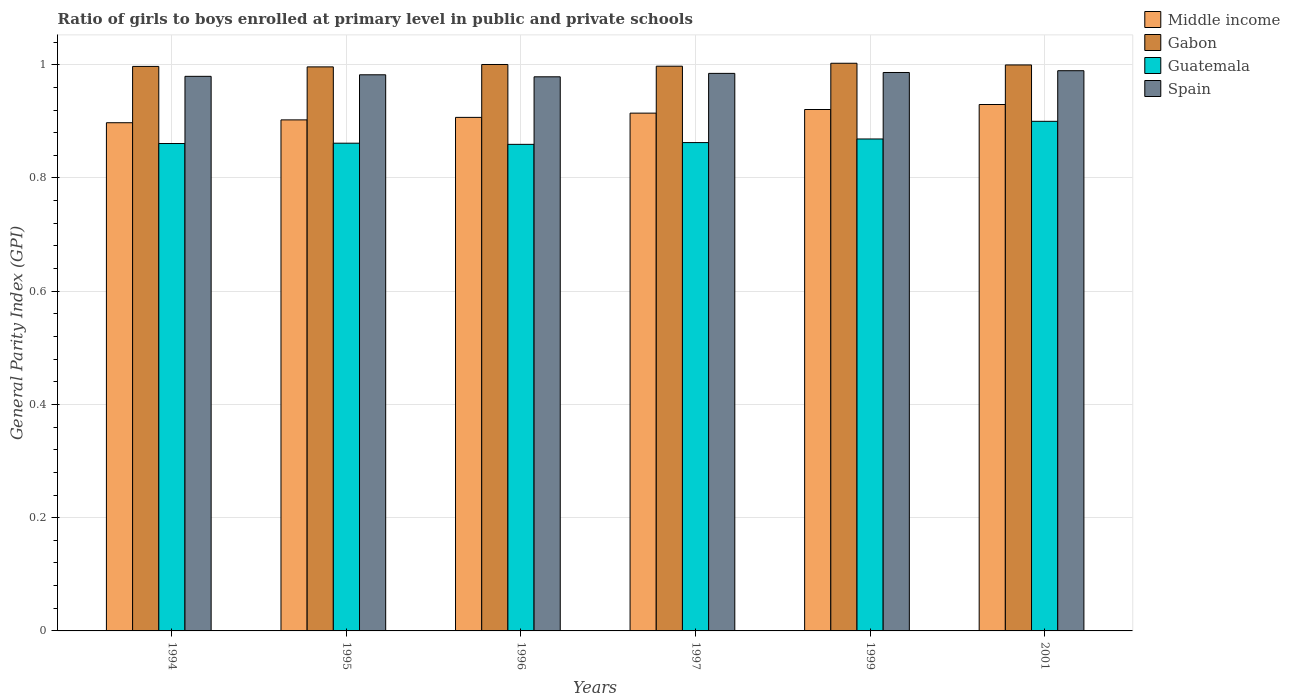How many different coloured bars are there?
Keep it short and to the point. 4. Are the number of bars per tick equal to the number of legend labels?
Offer a very short reply. Yes. Are the number of bars on each tick of the X-axis equal?
Provide a succinct answer. Yes. How many bars are there on the 4th tick from the right?
Offer a very short reply. 4. What is the label of the 5th group of bars from the left?
Provide a succinct answer. 1999. What is the general parity index in Gabon in 1999?
Make the answer very short. 1. Across all years, what is the maximum general parity index in Middle income?
Offer a terse response. 0.93. Across all years, what is the minimum general parity index in Gabon?
Provide a succinct answer. 1. In which year was the general parity index in Gabon maximum?
Give a very brief answer. 1999. What is the total general parity index in Guatemala in the graph?
Provide a short and direct response. 5.21. What is the difference between the general parity index in Gabon in 1996 and that in 2001?
Your answer should be compact. 0. What is the difference between the general parity index in Gabon in 2001 and the general parity index in Middle income in 1996?
Ensure brevity in your answer.  0.09. What is the average general parity index in Guatemala per year?
Give a very brief answer. 0.87. In the year 1997, what is the difference between the general parity index in Spain and general parity index in Middle income?
Give a very brief answer. 0.07. What is the ratio of the general parity index in Gabon in 1994 to that in 1999?
Give a very brief answer. 0.99. Is the general parity index in Guatemala in 1994 less than that in 2001?
Your response must be concise. Yes. Is the difference between the general parity index in Spain in 1994 and 1995 greater than the difference between the general parity index in Middle income in 1994 and 1995?
Offer a very short reply. Yes. What is the difference between the highest and the second highest general parity index in Middle income?
Provide a short and direct response. 0.01. What is the difference between the highest and the lowest general parity index in Middle income?
Make the answer very short. 0.03. Is it the case that in every year, the sum of the general parity index in Guatemala and general parity index in Middle income is greater than the sum of general parity index in Spain and general parity index in Gabon?
Offer a very short reply. No. What does the 2nd bar from the left in 1999 represents?
Provide a succinct answer. Gabon. What does the 2nd bar from the right in 1995 represents?
Your answer should be very brief. Guatemala. How many bars are there?
Offer a terse response. 24. What is the difference between two consecutive major ticks on the Y-axis?
Offer a very short reply. 0.2. Are the values on the major ticks of Y-axis written in scientific E-notation?
Provide a succinct answer. No. Does the graph contain grids?
Ensure brevity in your answer.  Yes. Where does the legend appear in the graph?
Your answer should be very brief. Top right. How many legend labels are there?
Keep it short and to the point. 4. How are the legend labels stacked?
Provide a short and direct response. Vertical. What is the title of the graph?
Offer a very short reply. Ratio of girls to boys enrolled at primary level in public and private schools. What is the label or title of the X-axis?
Your response must be concise. Years. What is the label or title of the Y-axis?
Provide a succinct answer. General Parity Index (GPI). What is the General Parity Index (GPI) in Middle income in 1994?
Provide a short and direct response. 0.9. What is the General Parity Index (GPI) of Gabon in 1994?
Your answer should be very brief. 1. What is the General Parity Index (GPI) in Guatemala in 1994?
Give a very brief answer. 0.86. What is the General Parity Index (GPI) in Spain in 1994?
Provide a short and direct response. 0.98. What is the General Parity Index (GPI) in Middle income in 1995?
Provide a succinct answer. 0.9. What is the General Parity Index (GPI) in Gabon in 1995?
Give a very brief answer. 1. What is the General Parity Index (GPI) in Guatemala in 1995?
Offer a terse response. 0.86. What is the General Parity Index (GPI) in Spain in 1995?
Provide a succinct answer. 0.98. What is the General Parity Index (GPI) in Middle income in 1996?
Offer a terse response. 0.91. What is the General Parity Index (GPI) in Gabon in 1996?
Your answer should be compact. 1. What is the General Parity Index (GPI) in Guatemala in 1996?
Your answer should be very brief. 0.86. What is the General Parity Index (GPI) in Spain in 1996?
Make the answer very short. 0.98. What is the General Parity Index (GPI) of Middle income in 1997?
Your answer should be compact. 0.91. What is the General Parity Index (GPI) in Gabon in 1997?
Your response must be concise. 1. What is the General Parity Index (GPI) of Guatemala in 1997?
Ensure brevity in your answer.  0.86. What is the General Parity Index (GPI) of Spain in 1997?
Your answer should be very brief. 0.98. What is the General Parity Index (GPI) in Middle income in 1999?
Provide a short and direct response. 0.92. What is the General Parity Index (GPI) in Gabon in 1999?
Your response must be concise. 1. What is the General Parity Index (GPI) of Guatemala in 1999?
Keep it short and to the point. 0.87. What is the General Parity Index (GPI) in Spain in 1999?
Provide a succinct answer. 0.99. What is the General Parity Index (GPI) in Middle income in 2001?
Keep it short and to the point. 0.93. What is the General Parity Index (GPI) of Gabon in 2001?
Keep it short and to the point. 1. What is the General Parity Index (GPI) in Guatemala in 2001?
Your answer should be compact. 0.9. What is the General Parity Index (GPI) of Spain in 2001?
Your answer should be very brief. 0.99. Across all years, what is the maximum General Parity Index (GPI) in Middle income?
Ensure brevity in your answer.  0.93. Across all years, what is the maximum General Parity Index (GPI) in Gabon?
Give a very brief answer. 1. Across all years, what is the maximum General Parity Index (GPI) of Guatemala?
Provide a short and direct response. 0.9. Across all years, what is the maximum General Parity Index (GPI) in Spain?
Your answer should be very brief. 0.99. Across all years, what is the minimum General Parity Index (GPI) in Middle income?
Your answer should be very brief. 0.9. Across all years, what is the minimum General Parity Index (GPI) of Gabon?
Make the answer very short. 1. Across all years, what is the minimum General Parity Index (GPI) of Guatemala?
Ensure brevity in your answer.  0.86. Across all years, what is the minimum General Parity Index (GPI) of Spain?
Offer a very short reply. 0.98. What is the total General Parity Index (GPI) of Middle income in the graph?
Keep it short and to the point. 5.47. What is the total General Parity Index (GPI) in Gabon in the graph?
Your answer should be very brief. 5.99. What is the total General Parity Index (GPI) in Guatemala in the graph?
Make the answer very short. 5.21. What is the total General Parity Index (GPI) in Spain in the graph?
Keep it short and to the point. 5.9. What is the difference between the General Parity Index (GPI) in Middle income in 1994 and that in 1995?
Ensure brevity in your answer.  -0.01. What is the difference between the General Parity Index (GPI) of Gabon in 1994 and that in 1995?
Make the answer very short. 0. What is the difference between the General Parity Index (GPI) in Guatemala in 1994 and that in 1995?
Your answer should be very brief. -0. What is the difference between the General Parity Index (GPI) in Spain in 1994 and that in 1995?
Provide a succinct answer. -0. What is the difference between the General Parity Index (GPI) in Middle income in 1994 and that in 1996?
Keep it short and to the point. -0.01. What is the difference between the General Parity Index (GPI) in Gabon in 1994 and that in 1996?
Offer a terse response. -0. What is the difference between the General Parity Index (GPI) of Guatemala in 1994 and that in 1996?
Provide a succinct answer. 0. What is the difference between the General Parity Index (GPI) of Spain in 1994 and that in 1996?
Make the answer very short. 0. What is the difference between the General Parity Index (GPI) of Middle income in 1994 and that in 1997?
Your response must be concise. -0.02. What is the difference between the General Parity Index (GPI) in Gabon in 1994 and that in 1997?
Make the answer very short. -0. What is the difference between the General Parity Index (GPI) in Guatemala in 1994 and that in 1997?
Keep it short and to the point. -0. What is the difference between the General Parity Index (GPI) in Spain in 1994 and that in 1997?
Give a very brief answer. -0.01. What is the difference between the General Parity Index (GPI) in Middle income in 1994 and that in 1999?
Ensure brevity in your answer.  -0.02. What is the difference between the General Parity Index (GPI) of Gabon in 1994 and that in 1999?
Give a very brief answer. -0.01. What is the difference between the General Parity Index (GPI) in Guatemala in 1994 and that in 1999?
Offer a terse response. -0.01. What is the difference between the General Parity Index (GPI) in Spain in 1994 and that in 1999?
Your answer should be very brief. -0.01. What is the difference between the General Parity Index (GPI) in Middle income in 1994 and that in 2001?
Your answer should be very brief. -0.03. What is the difference between the General Parity Index (GPI) of Gabon in 1994 and that in 2001?
Provide a succinct answer. -0. What is the difference between the General Parity Index (GPI) in Guatemala in 1994 and that in 2001?
Your answer should be compact. -0.04. What is the difference between the General Parity Index (GPI) in Spain in 1994 and that in 2001?
Your answer should be very brief. -0.01. What is the difference between the General Parity Index (GPI) in Middle income in 1995 and that in 1996?
Ensure brevity in your answer.  -0. What is the difference between the General Parity Index (GPI) of Gabon in 1995 and that in 1996?
Keep it short and to the point. -0. What is the difference between the General Parity Index (GPI) in Guatemala in 1995 and that in 1996?
Your response must be concise. 0. What is the difference between the General Parity Index (GPI) in Spain in 1995 and that in 1996?
Your response must be concise. 0. What is the difference between the General Parity Index (GPI) of Middle income in 1995 and that in 1997?
Make the answer very short. -0.01. What is the difference between the General Parity Index (GPI) in Gabon in 1995 and that in 1997?
Provide a short and direct response. -0. What is the difference between the General Parity Index (GPI) of Guatemala in 1995 and that in 1997?
Keep it short and to the point. -0. What is the difference between the General Parity Index (GPI) of Spain in 1995 and that in 1997?
Offer a terse response. -0. What is the difference between the General Parity Index (GPI) in Middle income in 1995 and that in 1999?
Your answer should be compact. -0.02. What is the difference between the General Parity Index (GPI) in Gabon in 1995 and that in 1999?
Give a very brief answer. -0.01. What is the difference between the General Parity Index (GPI) in Guatemala in 1995 and that in 1999?
Give a very brief answer. -0.01. What is the difference between the General Parity Index (GPI) in Spain in 1995 and that in 1999?
Provide a succinct answer. -0. What is the difference between the General Parity Index (GPI) of Middle income in 1995 and that in 2001?
Offer a terse response. -0.03. What is the difference between the General Parity Index (GPI) of Gabon in 1995 and that in 2001?
Make the answer very short. -0. What is the difference between the General Parity Index (GPI) of Guatemala in 1995 and that in 2001?
Ensure brevity in your answer.  -0.04. What is the difference between the General Parity Index (GPI) of Spain in 1995 and that in 2001?
Your answer should be very brief. -0.01. What is the difference between the General Parity Index (GPI) of Middle income in 1996 and that in 1997?
Keep it short and to the point. -0.01. What is the difference between the General Parity Index (GPI) of Gabon in 1996 and that in 1997?
Give a very brief answer. 0. What is the difference between the General Parity Index (GPI) of Guatemala in 1996 and that in 1997?
Provide a succinct answer. -0. What is the difference between the General Parity Index (GPI) of Spain in 1996 and that in 1997?
Provide a short and direct response. -0.01. What is the difference between the General Parity Index (GPI) in Middle income in 1996 and that in 1999?
Provide a succinct answer. -0.01. What is the difference between the General Parity Index (GPI) in Gabon in 1996 and that in 1999?
Make the answer very short. -0. What is the difference between the General Parity Index (GPI) of Guatemala in 1996 and that in 1999?
Make the answer very short. -0.01. What is the difference between the General Parity Index (GPI) in Spain in 1996 and that in 1999?
Provide a succinct answer. -0.01. What is the difference between the General Parity Index (GPI) in Middle income in 1996 and that in 2001?
Offer a terse response. -0.02. What is the difference between the General Parity Index (GPI) in Gabon in 1996 and that in 2001?
Your response must be concise. 0. What is the difference between the General Parity Index (GPI) of Guatemala in 1996 and that in 2001?
Provide a succinct answer. -0.04. What is the difference between the General Parity Index (GPI) of Spain in 1996 and that in 2001?
Your answer should be compact. -0.01. What is the difference between the General Parity Index (GPI) in Middle income in 1997 and that in 1999?
Provide a short and direct response. -0.01. What is the difference between the General Parity Index (GPI) of Gabon in 1997 and that in 1999?
Offer a very short reply. -0.01. What is the difference between the General Parity Index (GPI) in Guatemala in 1997 and that in 1999?
Provide a short and direct response. -0.01. What is the difference between the General Parity Index (GPI) in Spain in 1997 and that in 1999?
Give a very brief answer. -0. What is the difference between the General Parity Index (GPI) of Middle income in 1997 and that in 2001?
Your answer should be compact. -0.02. What is the difference between the General Parity Index (GPI) of Gabon in 1997 and that in 2001?
Provide a succinct answer. -0. What is the difference between the General Parity Index (GPI) in Guatemala in 1997 and that in 2001?
Offer a terse response. -0.04. What is the difference between the General Parity Index (GPI) of Spain in 1997 and that in 2001?
Your response must be concise. -0. What is the difference between the General Parity Index (GPI) of Middle income in 1999 and that in 2001?
Provide a succinct answer. -0.01. What is the difference between the General Parity Index (GPI) of Gabon in 1999 and that in 2001?
Keep it short and to the point. 0. What is the difference between the General Parity Index (GPI) of Guatemala in 1999 and that in 2001?
Provide a short and direct response. -0.03. What is the difference between the General Parity Index (GPI) of Spain in 1999 and that in 2001?
Keep it short and to the point. -0. What is the difference between the General Parity Index (GPI) in Middle income in 1994 and the General Parity Index (GPI) in Gabon in 1995?
Provide a short and direct response. -0.1. What is the difference between the General Parity Index (GPI) of Middle income in 1994 and the General Parity Index (GPI) of Guatemala in 1995?
Your answer should be very brief. 0.04. What is the difference between the General Parity Index (GPI) of Middle income in 1994 and the General Parity Index (GPI) of Spain in 1995?
Ensure brevity in your answer.  -0.08. What is the difference between the General Parity Index (GPI) of Gabon in 1994 and the General Parity Index (GPI) of Guatemala in 1995?
Provide a short and direct response. 0.14. What is the difference between the General Parity Index (GPI) in Gabon in 1994 and the General Parity Index (GPI) in Spain in 1995?
Offer a very short reply. 0.01. What is the difference between the General Parity Index (GPI) of Guatemala in 1994 and the General Parity Index (GPI) of Spain in 1995?
Ensure brevity in your answer.  -0.12. What is the difference between the General Parity Index (GPI) of Middle income in 1994 and the General Parity Index (GPI) of Gabon in 1996?
Provide a succinct answer. -0.1. What is the difference between the General Parity Index (GPI) in Middle income in 1994 and the General Parity Index (GPI) in Guatemala in 1996?
Your answer should be compact. 0.04. What is the difference between the General Parity Index (GPI) of Middle income in 1994 and the General Parity Index (GPI) of Spain in 1996?
Offer a terse response. -0.08. What is the difference between the General Parity Index (GPI) of Gabon in 1994 and the General Parity Index (GPI) of Guatemala in 1996?
Offer a very short reply. 0.14. What is the difference between the General Parity Index (GPI) of Gabon in 1994 and the General Parity Index (GPI) of Spain in 1996?
Make the answer very short. 0.02. What is the difference between the General Parity Index (GPI) in Guatemala in 1994 and the General Parity Index (GPI) in Spain in 1996?
Offer a terse response. -0.12. What is the difference between the General Parity Index (GPI) in Middle income in 1994 and the General Parity Index (GPI) in Gabon in 1997?
Offer a terse response. -0.1. What is the difference between the General Parity Index (GPI) in Middle income in 1994 and the General Parity Index (GPI) in Guatemala in 1997?
Keep it short and to the point. 0.04. What is the difference between the General Parity Index (GPI) of Middle income in 1994 and the General Parity Index (GPI) of Spain in 1997?
Keep it short and to the point. -0.09. What is the difference between the General Parity Index (GPI) in Gabon in 1994 and the General Parity Index (GPI) in Guatemala in 1997?
Offer a very short reply. 0.13. What is the difference between the General Parity Index (GPI) of Gabon in 1994 and the General Parity Index (GPI) of Spain in 1997?
Offer a very short reply. 0.01. What is the difference between the General Parity Index (GPI) in Guatemala in 1994 and the General Parity Index (GPI) in Spain in 1997?
Provide a short and direct response. -0.12. What is the difference between the General Parity Index (GPI) in Middle income in 1994 and the General Parity Index (GPI) in Gabon in 1999?
Offer a terse response. -0.1. What is the difference between the General Parity Index (GPI) of Middle income in 1994 and the General Parity Index (GPI) of Guatemala in 1999?
Your response must be concise. 0.03. What is the difference between the General Parity Index (GPI) in Middle income in 1994 and the General Parity Index (GPI) in Spain in 1999?
Your answer should be compact. -0.09. What is the difference between the General Parity Index (GPI) of Gabon in 1994 and the General Parity Index (GPI) of Guatemala in 1999?
Ensure brevity in your answer.  0.13. What is the difference between the General Parity Index (GPI) in Gabon in 1994 and the General Parity Index (GPI) in Spain in 1999?
Ensure brevity in your answer.  0.01. What is the difference between the General Parity Index (GPI) in Guatemala in 1994 and the General Parity Index (GPI) in Spain in 1999?
Your answer should be very brief. -0.13. What is the difference between the General Parity Index (GPI) of Middle income in 1994 and the General Parity Index (GPI) of Gabon in 2001?
Your response must be concise. -0.1. What is the difference between the General Parity Index (GPI) in Middle income in 1994 and the General Parity Index (GPI) in Guatemala in 2001?
Keep it short and to the point. -0. What is the difference between the General Parity Index (GPI) in Middle income in 1994 and the General Parity Index (GPI) in Spain in 2001?
Provide a short and direct response. -0.09. What is the difference between the General Parity Index (GPI) of Gabon in 1994 and the General Parity Index (GPI) of Guatemala in 2001?
Provide a succinct answer. 0.1. What is the difference between the General Parity Index (GPI) of Gabon in 1994 and the General Parity Index (GPI) of Spain in 2001?
Provide a succinct answer. 0.01. What is the difference between the General Parity Index (GPI) in Guatemala in 1994 and the General Parity Index (GPI) in Spain in 2001?
Offer a terse response. -0.13. What is the difference between the General Parity Index (GPI) of Middle income in 1995 and the General Parity Index (GPI) of Gabon in 1996?
Offer a very short reply. -0.1. What is the difference between the General Parity Index (GPI) in Middle income in 1995 and the General Parity Index (GPI) in Guatemala in 1996?
Ensure brevity in your answer.  0.04. What is the difference between the General Parity Index (GPI) of Middle income in 1995 and the General Parity Index (GPI) of Spain in 1996?
Keep it short and to the point. -0.08. What is the difference between the General Parity Index (GPI) of Gabon in 1995 and the General Parity Index (GPI) of Guatemala in 1996?
Ensure brevity in your answer.  0.14. What is the difference between the General Parity Index (GPI) of Gabon in 1995 and the General Parity Index (GPI) of Spain in 1996?
Your answer should be compact. 0.02. What is the difference between the General Parity Index (GPI) in Guatemala in 1995 and the General Parity Index (GPI) in Spain in 1996?
Offer a very short reply. -0.12. What is the difference between the General Parity Index (GPI) in Middle income in 1995 and the General Parity Index (GPI) in Gabon in 1997?
Your answer should be compact. -0.09. What is the difference between the General Parity Index (GPI) of Middle income in 1995 and the General Parity Index (GPI) of Guatemala in 1997?
Offer a terse response. 0.04. What is the difference between the General Parity Index (GPI) in Middle income in 1995 and the General Parity Index (GPI) in Spain in 1997?
Your answer should be compact. -0.08. What is the difference between the General Parity Index (GPI) of Gabon in 1995 and the General Parity Index (GPI) of Guatemala in 1997?
Your answer should be compact. 0.13. What is the difference between the General Parity Index (GPI) of Gabon in 1995 and the General Parity Index (GPI) of Spain in 1997?
Your answer should be very brief. 0.01. What is the difference between the General Parity Index (GPI) of Guatemala in 1995 and the General Parity Index (GPI) of Spain in 1997?
Your answer should be very brief. -0.12. What is the difference between the General Parity Index (GPI) in Middle income in 1995 and the General Parity Index (GPI) in Guatemala in 1999?
Provide a short and direct response. 0.03. What is the difference between the General Parity Index (GPI) in Middle income in 1995 and the General Parity Index (GPI) in Spain in 1999?
Provide a short and direct response. -0.08. What is the difference between the General Parity Index (GPI) of Gabon in 1995 and the General Parity Index (GPI) of Guatemala in 1999?
Offer a terse response. 0.13. What is the difference between the General Parity Index (GPI) of Gabon in 1995 and the General Parity Index (GPI) of Spain in 1999?
Your answer should be compact. 0.01. What is the difference between the General Parity Index (GPI) of Guatemala in 1995 and the General Parity Index (GPI) of Spain in 1999?
Your response must be concise. -0.12. What is the difference between the General Parity Index (GPI) in Middle income in 1995 and the General Parity Index (GPI) in Gabon in 2001?
Offer a very short reply. -0.1. What is the difference between the General Parity Index (GPI) of Middle income in 1995 and the General Parity Index (GPI) of Guatemala in 2001?
Give a very brief answer. 0. What is the difference between the General Parity Index (GPI) in Middle income in 1995 and the General Parity Index (GPI) in Spain in 2001?
Provide a succinct answer. -0.09. What is the difference between the General Parity Index (GPI) in Gabon in 1995 and the General Parity Index (GPI) in Guatemala in 2001?
Your answer should be very brief. 0.1. What is the difference between the General Parity Index (GPI) in Gabon in 1995 and the General Parity Index (GPI) in Spain in 2001?
Offer a terse response. 0.01. What is the difference between the General Parity Index (GPI) of Guatemala in 1995 and the General Parity Index (GPI) of Spain in 2001?
Your response must be concise. -0.13. What is the difference between the General Parity Index (GPI) of Middle income in 1996 and the General Parity Index (GPI) of Gabon in 1997?
Ensure brevity in your answer.  -0.09. What is the difference between the General Parity Index (GPI) in Middle income in 1996 and the General Parity Index (GPI) in Guatemala in 1997?
Offer a very short reply. 0.04. What is the difference between the General Parity Index (GPI) in Middle income in 1996 and the General Parity Index (GPI) in Spain in 1997?
Offer a very short reply. -0.08. What is the difference between the General Parity Index (GPI) in Gabon in 1996 and the General Parity Index (GPI) in Guatemala in 1997?
Make the answer very short. 0.14. What is the difference between the General Parity Index (GPI) of Gabon in 1996 and the General Parity Index (GPI) of Spain in 1997?
Provide a short and direct response. 0.02. What is the difference between the General Parity Index (GPI) of Guatemala in 1996 and the General Parity Index (GPI) of Spain in 1997?
Give a very brief answer. -0.13. What is the difference between the General Parity Index (GPI) in Middle income in 1996 and the General Parity Index (GPI) in Gabon in 1999?
Ensure brevity in your answer.  -0.1. What is the difference between the General Parity Index (GPI) in Middle income in 1996 and the General Parity Index (GPI) in Guatemala in 1999?
Provide a succinct answer. 0.04. What is the difference between the General Parity Index (GPI) of Middle income in 1996 and the General Parity Index (GPI) of Spain in 1999?
Your response must be concise. -0.08. What is the difference between the General Parity Index (GPI) of Gabon in 1996 and the General Parity Index (GPI) of Guatemala in 1999?
Provide a short and direct response. 0.13. What is the difference between the General Parity Index (GPI) in Gabon in 1996 and the General Parity Index (GPI) in Spain in 1999?
Provide a short and direct response. 0.01. What is the difference between the General Parity Index (GPI) of Guatemala in 1996 and the General Parity Index (GPI) of Spain in 1999?
Your response must be concise. -0.13. What is the difference between the General Parity Index (GPI) in Middle income in 1996 and the General Parity Index (GPI) in Gabon in 2001?
Provide a succinct answer. -0.09. What is the difference between the General Parity Index (GPI) in Middle income in 1996 and the General Parity Index (GPI) in Guatemala in 2001?
Provide a short and direct response. 0.01. What is the difference between the General Parity Index (GPI) of Middle income in 1996 and the General Parity Index (GPI) of Spain in 2001?
Ensure brevity in your answer.  -0.08. What is the difference between the General Parity Index (GPI) of Gabon in 1996 and the General Parity Index (GPI) of Guatemala in 2001?
Provide a succinct answer. 0.1. What is the difference between the General Parity Index (GPI) of Gabon in 1996 and the General Parity Index (GPI) of Spain in 2001?
Ensure brevity in your answer.  0.01. What is the difference between the General Parity Index (GPI) in Guatemala in 1996 and the General Parity Index (GPI) in Spain in 2001?
Offer a terse response. -0.13. What is the difference between the General Parity Index (GPI) of Middle income in 1997 and the General Parity Index (GPI) of Gabon in 1999?
Ensure brevity in your answer.  -0.09. What is the difference between the General Parity Index (GPI) in Middle income in 1997 and the General Parity Index (GPI) in Guatemala in 1999?
Give a very brief answer. 0.05. What is the difference between the General Parity Index (GPI) in Middle income in 1997 and the General Parity Index (GPI) in Spain in 1999?
Your response must be concise. -0.07. What is the difference between the General Parity Index (GPI) of Gabon in 1997 and the General Parity Index (GPI) of Guatemala in 1999?
Provide a succinct answer. 0.13. What is the difference between the General Parity Index (GPI) of Gabon in 1997 and the General Parity Index (GPI) of Spain in 1999?
Keep it short and to the point. 0.01. What is the difference between the General Parity Index (GPI) of Guatemala in 1997 and the General Parity Index (GPI) of Spain in 1999?
Offer a very short reply. -0.12. What is the difference between the General Parity Index (GPI) in Middle income in 1997 and the General Parity Index (GPI) in Gabon in 2001?
Offer a very short reply. -0.09. What is the difference between the General Parity Index (GPI) of Middle income in 1997 and the General Parity Index (GPI) of Guatemala in 2001?
Ensure brevity in your answer.  0.01. What is the difference between the General Parity Index (GPI) in Middle income in 1997 and the General Parity Index (GPI) in Spain in 2001?
Offer a terse response. -0.07. What is the difference between the General Parity Index (GPI) of Gabon in 1997 and the General Parity Index (GPI) of Guatemala in 2001?
Ensure brevity in your answer.  0.1. What is the difference between the General Parity Index (GPI) of Gabon in 1997 and the General Parity Index (GPI) of Spain in 2001?
Keep it short and to the point. 0.01. What is the difference between the General Parity Index (GPI) of Guatemala in 1997 and the General Parity Index (GPI) of Spain in 2001?
Your answer should be very brief. -0.13. What is the difference between the General Parity Index (GPI) in Middle income in 1999 and the General Parity Index (GPI) in Gabon in 2001?
Provide a succinct answer. -0.08. What is the difference between the General Parity Index (GPI) in Middle income in 1999 and the General Parity Index (GPI) in Guatemala in 2001?
Keep it short and to the point. 0.02. What is the difference between the General Parity Index (GPI) in Middle income in 1999 and the General Parity Index (GPI) in Spain in 2001?
Provide a succinct answer. -0.07. What is the difference between the General Parity Index (GPI) in Gabon in 1999 and the General Parity Index (GPI) in Guatemala in 2001?
Keep it short and to the point. 0.1. What is the difference between the General Parity Index (GPI) of Gabon in 1999 and the General Parity Index (GPI) of Spain in 2001?
Your answer should be compact. 0.01. What is the difference between the General Parity Index (GPI) of Guatemala in 1999 and the General Parity Index (GPI) of Spain in 2001?
Keep it short and to the point. -0.12. What is the average General Parity Index (GPI) of Middle income per year?
Provide a succinct answer. 0.91. What is the average General Parity Index (GPI) in Guatemala per year?
Provide a succinct answer. 0.87. What is the average General Parity Index (GPI) of Spain per year?
Offer a very short reply. 0.98. In the year 1994, what is the difference between the General Parity Index (GPI) of Middle income and General Parity Index (GPI) of Gabon?
Ensure brevity in your answer.  -0.1. In the year 1994, what is the difference between the General Parity Index (GPI) in Middle income and General Parity Index (GPI) in Guatemala?
Keep it short and to the point. 0.04. In the year 1994, what is the difference between the General Parity Index (GPI) of Middle income and General Parity Index (GPI) of Spain?
Your answer should be very brief. -0.08. In the year 1994, what is the difference between the General Parity Index (GPI) in Gabon and General Parity Index (GPI) in Guatemala?
Your answer should be very brief. 0.14. In the year 1994, what is the difference between the General Parity Index (GPI) of Gabon and General Parity Index (GPI) of Spain?
Provide a succinct answer. 0.02. In the year 1994, what is the difference between the General Parity Index (GPI) of Guatemala and General Parity Index (GPI) of Spain?
Provide a short and direct response. -0.12. In the year 1995, what is the difference between the General Parity Index (GPI) in Middle income and General Parity Index (GPI) in Gabon?
Provide a succinct answer. -0.09. In the year 1995, what is the difference between the General Parity Index (GPI) of Middle income and General Parity Index (GPI) of Guatemala?
Your response must be concise. 0.04. In the year 1995, what is the difference between the General Parity Index (GPI) of Middle income and General Parity Index (GPI) of Spain?
Give a very brief answer. -0.08. In the year 1995, what is the difference between the General Parity Index (GPI) in Gabon and General Parity Index (GPI) in Guatemala?
Provide a short and direct response. 0.13. In the year 1995, what is the difference between the General Parity Index (GPI) of Gabon and General Parity Index (GPI) of Spain?
Your answer should be very brief. 0.01. In the year 1995, what is the difference between the General Parity Index (GPI) of Guatemala and General Parity Index (GPI) of Spain?
Give a very brief answer. -0.12. In the year 1996, what is the difference between the General Parity Index (GPI) in Middle income and General Parity Index (GPI) in Gabon?
Ensure brevity in your answer.  -0.09. In the year 1996, what is the difference between the General Parity Index (GPI) of Middle income and General Parity Index (GPI) of Guatemala?
Keep it short and to the point. 0.05. In the year 1996, what is the difference between the General Parity Index (GPI) of Middle income and General Parity Index (GPI) of Spain?
Your response must be concise. -0.07. In the year 1996, what is the difference between the General Parity Index (GPI) of Gabon and General Parity Index (GPI) of Guatemala?
Keep it short and to the point. 0.14. In the year 1996, what is the difference between the General Parity Index (GPI) in Gabon and General Parity Index (GPI) in Spain?
Keep it short and to the point. 0.02. In the year 1996, what is the difference between the General Parity Index (GPI) in Guatemala and General Parity Index (GPI) in Spain?
Make the answer very short. -0.12. In the year 1997, what is the difference between the General Parity Index (GPI) in Middle income and General Parity Index (GPI) in Gabon?
Your answer should be compact. -0.08. In the year 1997, what is the difference between the General Parity Index (GPI) of Middle income and General Parity Index (GPI) of Guatemala?
Ensure brevity in your answer.  0.05. In the year 1997, what is the difference between the General Parity Index (GPI) of Middle income and General Parity Index (GPI) of Spain?
Give a very brief answer. -0.07. In the year 1997, what is the difference between the General Parity Index (GPI) of Gabon and General Parity Index (GPI) of Guatemala?
Your response must be concise. 0.13. In the year 1997, what is the difference between the General Parity Index (GPI) in Gabon and General Parity Index (GPI) in Spain?
Offer a terse response. 0.01. In the year 1997, what is the difference between the General Parity Index (GPI) in Guatemala and General Parity Index (GPI) in Spain?
Provide a short and direct response. -0.12. In the year 1999, what is the difference between the General Parity Index (GPI) of Middle income and General Parity Index (GPI) of Gabon?
Provide a succinct answer. -0.08. In the year 1999, what is the difference between the General Parity Index (GPI) of Middle income and General Parity Index (GPI) of Guatemala?
Offer a very short reply. 0.05. In the year 1999, what is the difference between the General Parity Index (GPI) in Middle income and General Parity Index (GPI) in Spain?
Provide a short and direct response. -0.07. In the year 1999, what is the difference between the General Parity Index (GPI) of Gabon and General Parity Index (GPI) of Guatemala?
Your response must be concise. 0.13. In the year 1999, what is the difference between the General Parity Index (GPI) in Gabon and General Parity Index (GPI) in Spain?
Ensure brevity in your answer.  0.02. In the year 1999, what is the difference between the General Parity Index (GPI) of Guatemala and General Parity Index (GPI) of Spain?
Keep it short and to the point. -0.12. In the year 2001, what is the difference between the General Parity Index (GPI) in Middle income and General Parity Index (GPI) in Gabon?
Your answer should be very brief. -0.07. In the year 2001, what is the difference between the General Parity Index (GPI) of Middle income and General Parity Index (GPI) of Guatemala?
Your answer should be compact. 0.03. In the year 2001, what is the difference between the General Parity Index (GPI) in Middle income and General Parity Index (GPI) in Spain?
Keep it short and to the point. -0.06. In the year 2001, what is the difference between the General Parity Index (GPI) of Gabon and General Parity Index (GPI) of Guatemala?
Offer a very short reply. 0.1. In the year 2001, what is the difference between the General Parity Index (GPI) in Gabon and General Parity Index (GPI) in Spain?
Provide a short and direct response. 0.01. In the year 2001, what is the difference between the General Parity Index (GPI) of Guatemala and General Parity Index (GPI) of Spain?
Offer a very short reply. -0.09. What is the ratio of the General Parity Index (GPI) in Gabon in 1994 to that in 1995?
Offer a very short reply. 1. What is the ratio of the General Parity Index (GPI) of Guatemala in 1994 to that in 1995?
Keep it short and to the point. 1. What is the ratio of the General Parity Index (GPI) of Gabon in 1994 to that in 1996?
Provide a succinct answer. 1. What is the ratio of the General Parity Index (GPI) of Middle income in 1994 to that in 1997?
Your response must be concise. 0.98. What is the ratio of the General Parity Index (GPI) in Gabon in 1994 to that in 1997?
Your answer should be compact. 1. What is the ratio of the General Parity Index (GPI) of Guatemala in 1994 to that in 1997?
Keep it short and to the point. 1. What is the ratio of the General Parity Index (GPI) in Middle income in 1994 to that in 1999?
Keep it short and to the point. 0.97. What is the ratio of the General Parity Index (GPI) in Gabon in 1994 to that in 1999?
Provide a succinct answer. 0.99. What is the ratio of the General Parity Index (GPI) in Guatemala in 1994 to that in 1999?
Your response must be concise. 0.99. What is the ratio of the General Parity Index (GPI) of Middle income in 1994 to that in 2001?
Make the answer very short. 0.97. What is the ratio of the General Parity Index (GPI) of Gabon in 1994 to that in 2001?
Offer a terse response. 1. What is the ratio of the General Parity Index (GPI) of Guatemala in 1994 to that in 2001?
Provide a short and direct response. 0.96. What is the ratio of the General Parity Index (GPI) in Spain in 1994 to that in 2001?
Your response must be concise. 0.99. What is the ratio of the General Parity Index (GPI) of Guatemala in 1995 to that in 1996?
Keep it short and to the point. 1. What is the ratio of the General Parity Index (GPI) of Gabon in 1995 to that in 1997?
Provide a succinct answer. 1. What is the ratio of the General Parity Index (GPI) of Guatemala in 1995 to that in 1997?
Give a very brief answer. 1. What is the ratio of the General Parity Index (GPI) of Middle income in 1995 to that in 1999?
Offer a terse response. 0.98. What is the ratio of the General Parity Index (GPI) of Middle income in 1995 to that in 2001?
Offer a terse response. 0.97. What is the ratio of the General Parity Index (GPI) in Gabon in 1995 to that in 2001?
Your answer should be compact. 1. What is the ratio of the General Parity Index (GPI) in Guatemala in 1995 to that in 2001?
Provide a short and direct response. 0.96. What is the ratio of the General Parity Index (GPI) in Middle income in 1996 to that in 1997?
Make the answer very short. 0.99. What is the ratio of the General Parity Index (GPI) in Middle income in 1996 to that in 1999?
Offer a terse response. 0.98. What is the ratio of the General Parity Index (GPI) of Gabon in 1996 to that in 1999?
Provide a short and direct response. 1. What is the ratio of the General Parity Index (GPI) in Spain in 1996 to that in 1999?
Give a very brief answer. 0.99. What is the ratio of the General Parity Index (GPI) in Middle income in 1996 to that in 2001?
Offer a terse response. 0.98. What is the ratio of the General Parity Index (GPI) of Guatemala in 1996 to that in 2001?
Offer a very short reply. 0.95. What is the ratio of the General Parity Index (GPI) of Spain in 1996 to that in 2001?
Offer a very short reply. 0.99. What is the ratio of the General Parity Index (GPI) in Middle income in 1997 to that in 1999?
Make the answer very short. 0.99. What is the ratio of the General Parity Index (GPI) of Guatemala in 1997 to that in 1999?
Your response must be concise. 0.99. What is the ratio of the General Parity Index (GPI) of Middle income in 1997 to that in 2001?
Give a very brief answer. 0.98. What is the ratio of the General Parity Index (GPI) of Gabon in 1999 to that in 2001?
Keep it short and to the point. 1. What is the ratio of the General Parity Index (GPI) of Guatemala in 1999 to that in 2001?
Your answer should be compact. 0.97. What is the ratio of the General Parity Index (GPI) in Spain in 1999 to that in 2001?
Give a very brief answer. 1. What is the difference between the highest and the second highest General Parity Index (GPI) in Middle income?
Ensure brevity in your answer.  0.01. What is the difference between the highest and the second highest General Parity Index (GPI) of Gabon?
Ensure brevity in your answer.  0. What is the difference between the highest and the second highest General Parity Index (GPI) in Guatemala?
Ensure brevity in your answer.  0.03. What is the difference between the highest and the second highest General Parity Index (GPI) in Spain?
Offer a very short reply. 0. What is the difference between the highest and the lowest General Parity Index (GPI) of Middle income?
Provide a short and direct response. 0.03. What is the difference between the highest and the lowest General Parity Index (GPI) in Gabon?
Ensure brevity in your answer.  0.01. What is the difference between the highest and the lowest General Parity Index (GPI) in Guatemala?
Ensure brevity in your answer.  0.04. What is the difference between the highest and the lowest General Parity Index (GPI) of Spain?
Give a very brief answer. 0.01. 